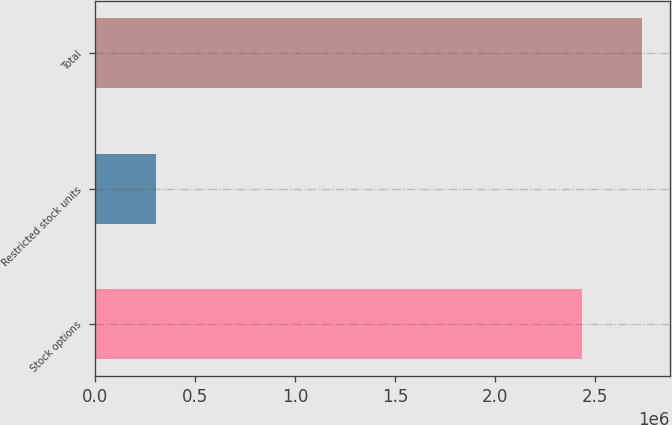Convert chart to OTSL. <chart><loc_0><loc_0><loc_500><loc_500><bar_chart><fcel>Stock options<fcel>Restricted stock units<fcel>Total<nl><fcel>2.43352e+06<fcel>302635<fcel>2.73615e+06<nl></chart> 